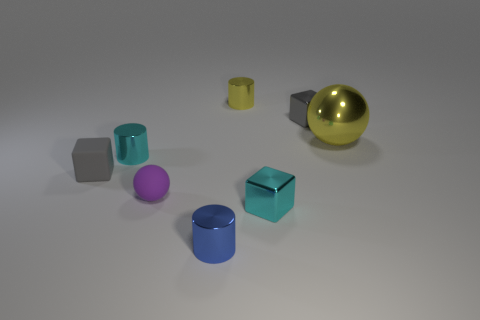What is the small cube that is both behind the purple rubber ball and to the right of the small yellow metallic thing made of?
Your response must be concise. Metal. Do the metal cylinder that is in front of the cyan shiny cube and the tiny gray rubber block have the same size?
Keep it short and to the point. Yes. Is the color of the small rubber ball the same as the metallic sphere?
Ensure brevity in your answer.  No. How many cylinders are both behind the large yellow sphere and in front of the tiny purple ball?
Offer a terse response. 0. There is a gray block to the left of the small gray block that is on the right side of the small yellow metal object; how many small objects are right of it?
Offer a terse response. 6. There is another object that is the same color as the big metallic thing; what size is it?
Give a very brief answer. Small. There is a big yellow metallic thing; what shape is it?
Give a very brief answer. Sphere. What number of purple things have the same material as the tiny cyan cube?
Give a very brief answer. 0. There is a tiny thing that is made of the same material as the tiny sphere; what is its color?
Make the answer very short. Gray. There is a yellow sphere; is its size the same as the metallic cylinder in front of the cyan cube?
Make the answer very short. No. 